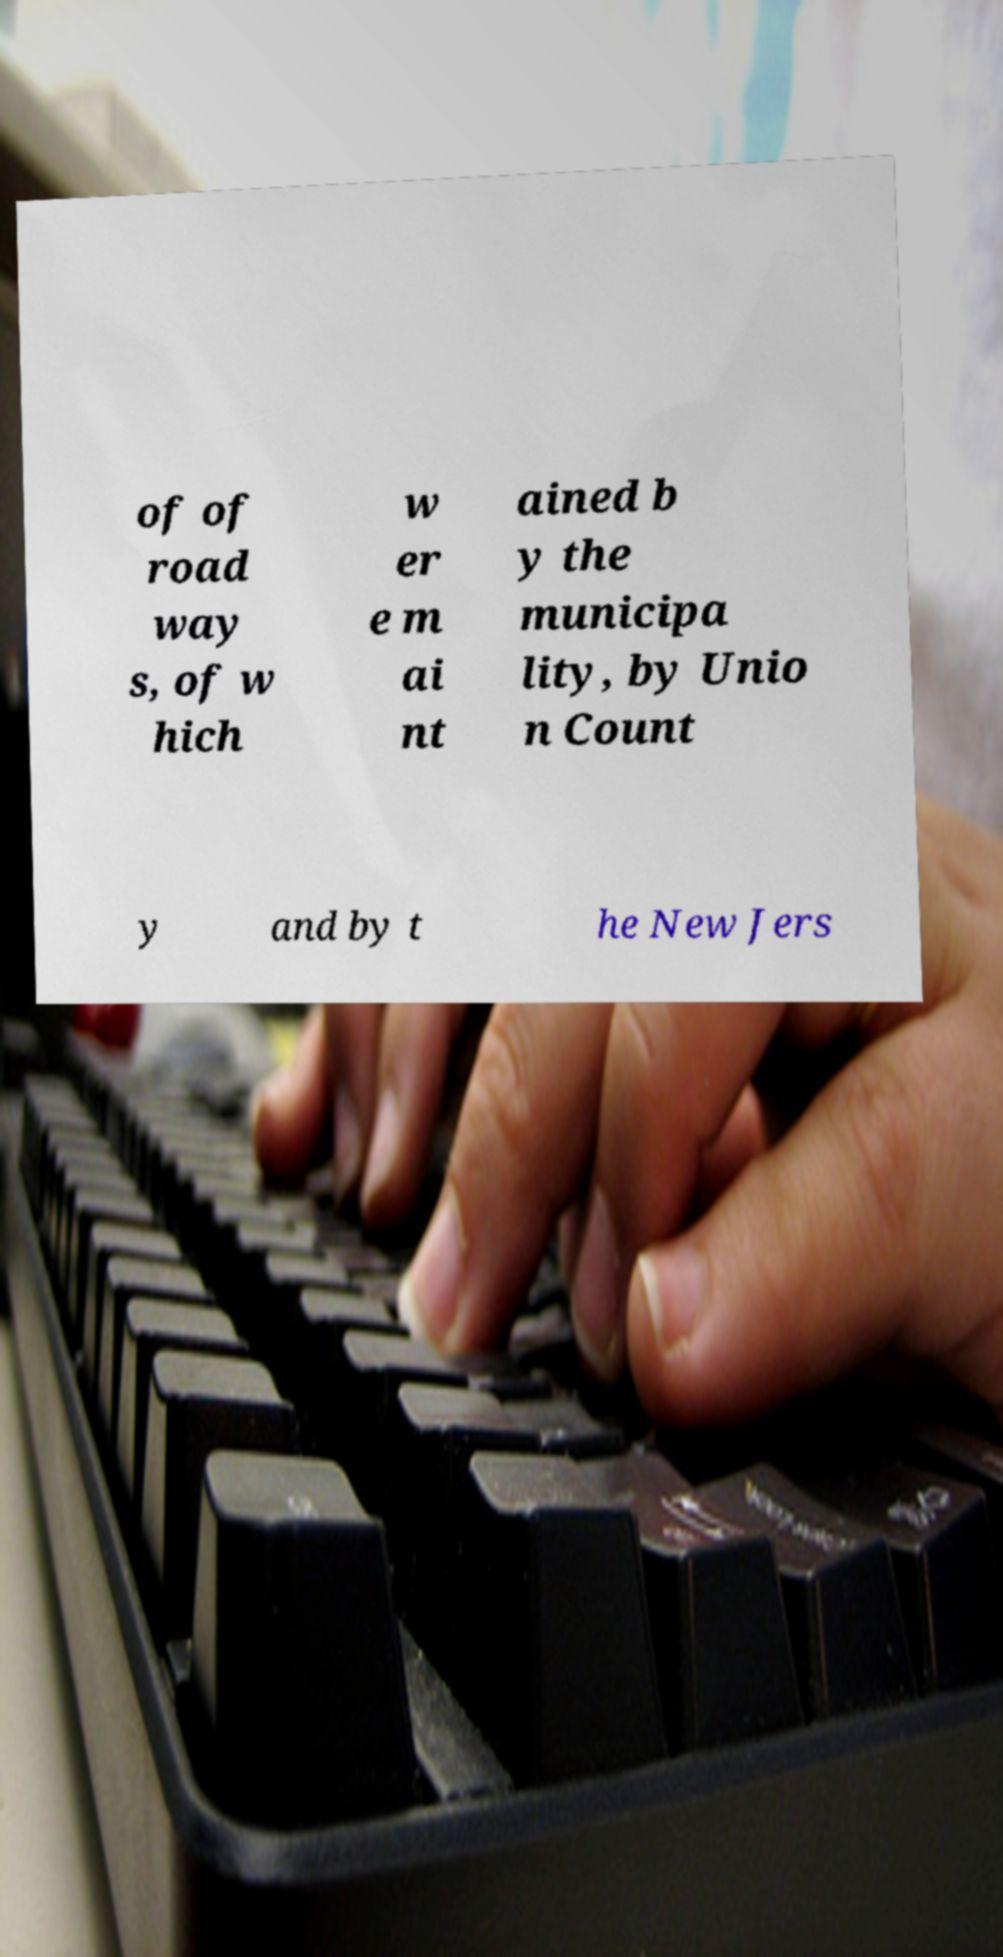For documentation purposes, I need the text within this image transcribed. Could you provide that? of of road way s, of w hich w er e m ai nt ained b y the municipa lity, by Unio n Count y and by t he New Jers 